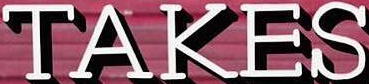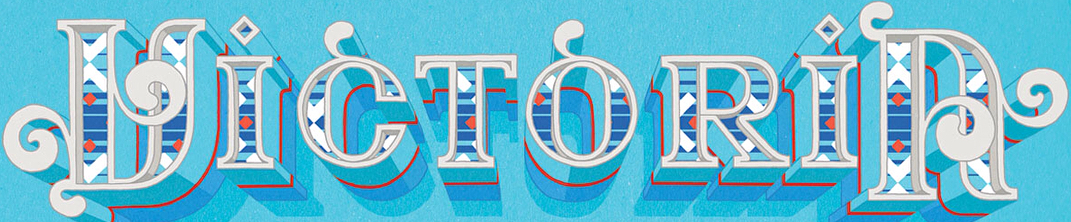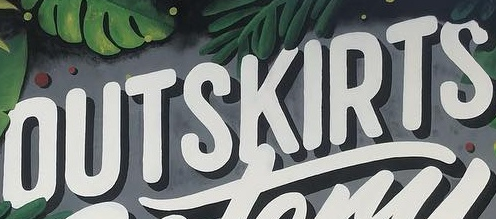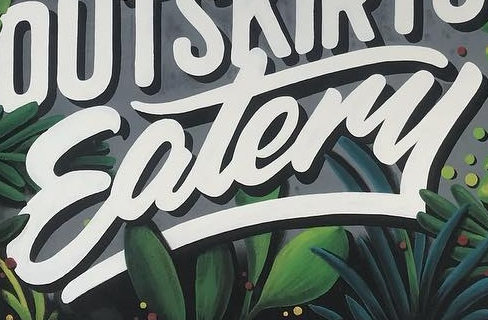What words are shown in these images in order, separated by a semicolon? TAKES; VICTORIA; OUTSKIRTS; Eatery 